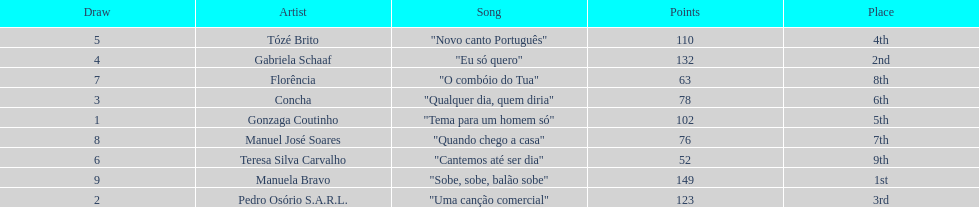Who sang "eu só quero" as their song in the eurovision song contest of 1979? Gabriela Schaaf. 